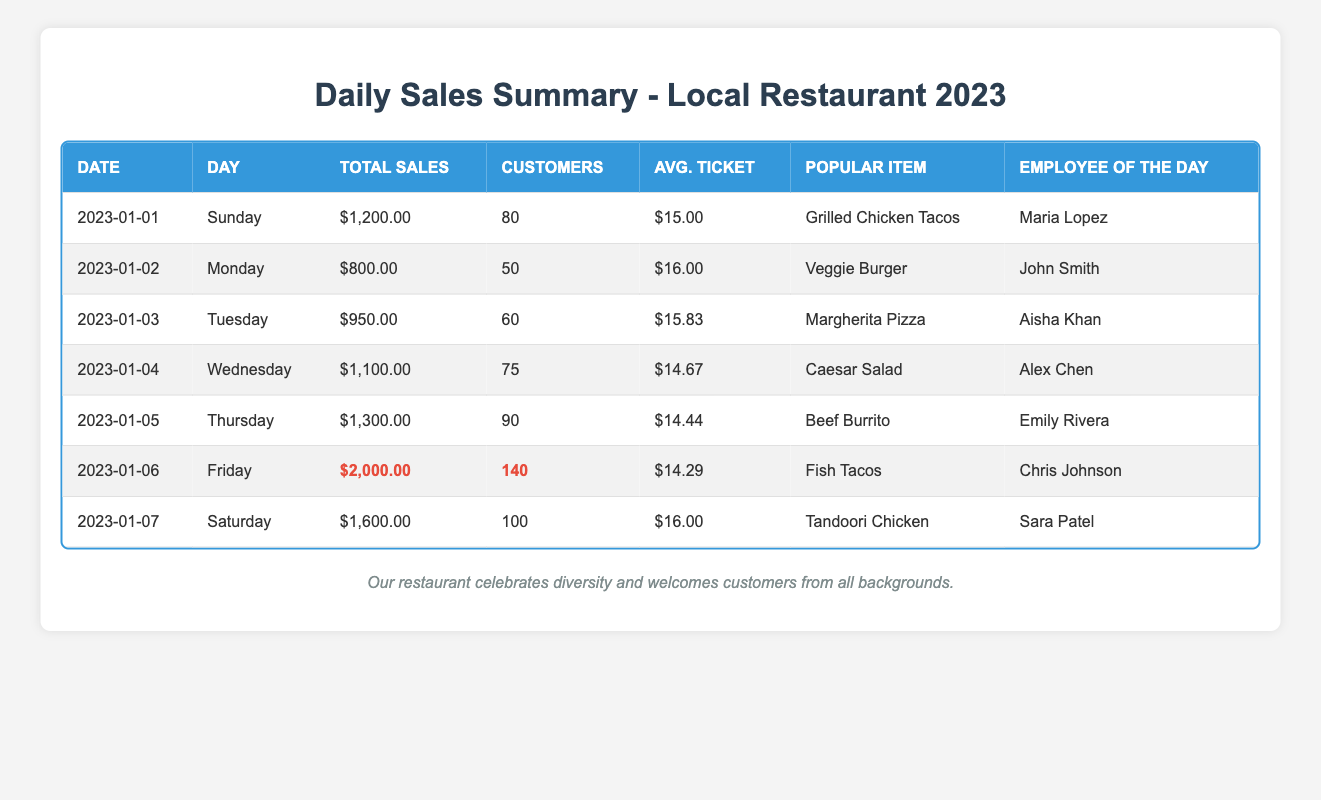What was the highest total sales recorded in a day? The maximum value in the total sales column is for January 6, which shows total sales of $2,000.00.
Answer: $2,000.00 Which day had the least number of customers? By comparing the total customers column, January 2 has the least number of customers at 50.
Answer: 50 What is the average ticket price for the week? Adding the average ticket prices (15.00 + 16.00 + 15.83 + 14.67 + 14.44 + 14.29 + 16.00) gives a total of $106.23. There are 7 days, so the average ticket price is $106.23 / 7 = $15.18.
Answer: $15.18 Did María Lopez work on the day with the highest sales? María Lopez was the employee of the day on January 1 when total sales were $1,200, not the day with the highest sales on January 6. Therefore, the statement is false.
Answer: No How many total customers visited the restaurant on Friday compared to Sunday? The total customers for Friday (January 6) is 140, and for Sunday (January 1) it's 80. The difference is 140 - 80 = 60 more customers on Friday.
Answer: 60 more customers On which day did the most popular item change from the previous day? By checking the most popular items for each day, we see that from January 2 (Veggie Burger) to January 3 (Margherita Pizza), the most popular item changed.
Answer: January 3 What was the combined total sales for Thursday and Saturday? Adding the total sales for Thursday ($1,300.00) and Saturday ($1,600.00) gives $1,300.00 + $1,600.00 = $2,900.00 in total sales for those two days.
Answer: $2,900.00 Is the average ticket price for Friday higher than that for Thursday? The average ticket price for Friday is $14.29, while for Thursday it is $14.44. Thus, the average ticket price for Friday is not higher than that for Thursday.
Answer: No Which employee had the most customers served on a single day? On January 6, Chris Johnson served 140 customers, which is the highest number of customers served by any employee on a single day.
Answer: Chris Johnson 